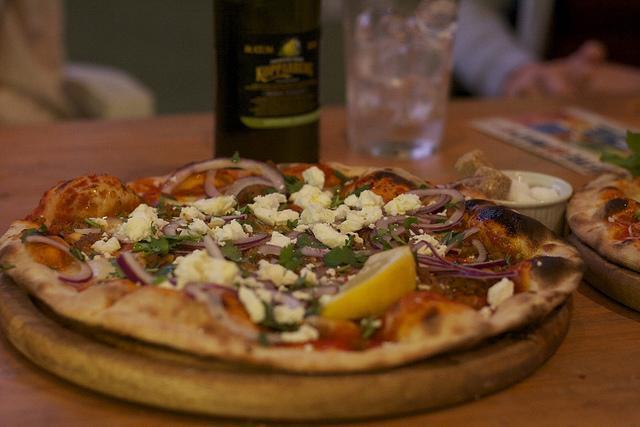How many people can you see?
Give a very brief answer. 2. How many pizzas are there?
Give a very brief answer. 2. How many animals that are zebras are there? there are animals that aren't zebras too?
Give a very brief answer. 0. 